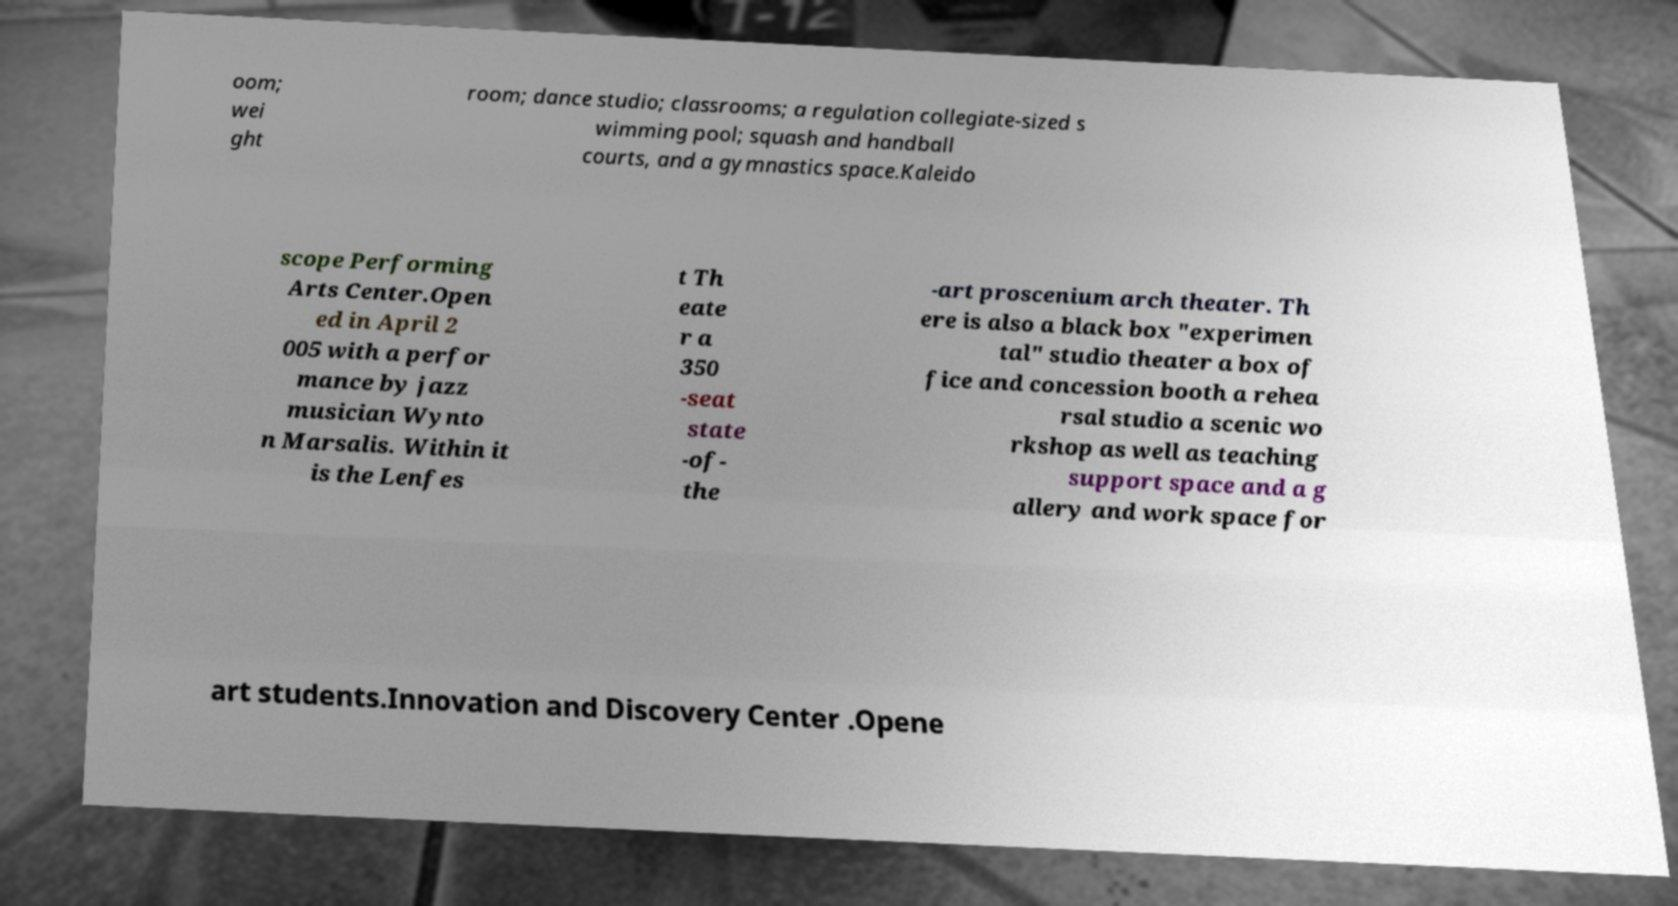There's text embedded in this image that I need extracted. Can you transcribe it verbatim? oom; wei ght room; dance studio; classrooms; a regulation collegiate-sized s wimming pool; squash and handball courts, and a gymnastics space.Kaleido scope Performing Arts Center.Open ed in April 2 005 with a perfor mance by jazz musician Wynto n Marsalis. Within it is the Lenfes t Th eate r a 350 -seat state -of- the -art proscenium arch theater. Th ere is also a black box "experimen tal" studio theater a box of fice and concession booth a rehea rsal studio a scenic wo rkshop as well as teaching support space and a g allery and work space for art students.Innovation and Discovery Center .Opene 